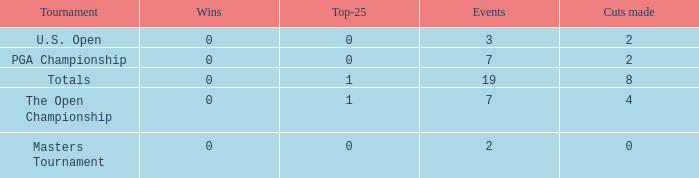Would you mind parsing the complete table? {'header': ['Tournament', 'Wins', 'Top-25', 'Events', 'Cuts made'], 'rows': [['U.S. Open', '0', '0', '3', '2'], ['PGA Championship', '0', '0', '7', '2'], ['Totals', '0', '1', '19', '8'], ['The Open Championship', '0', '1', '7', '4'], ['Masters Tournament', '0', '0', '2', '0']]} What is the total number of cuts made of tournaments with 2 Events? 1.0. 